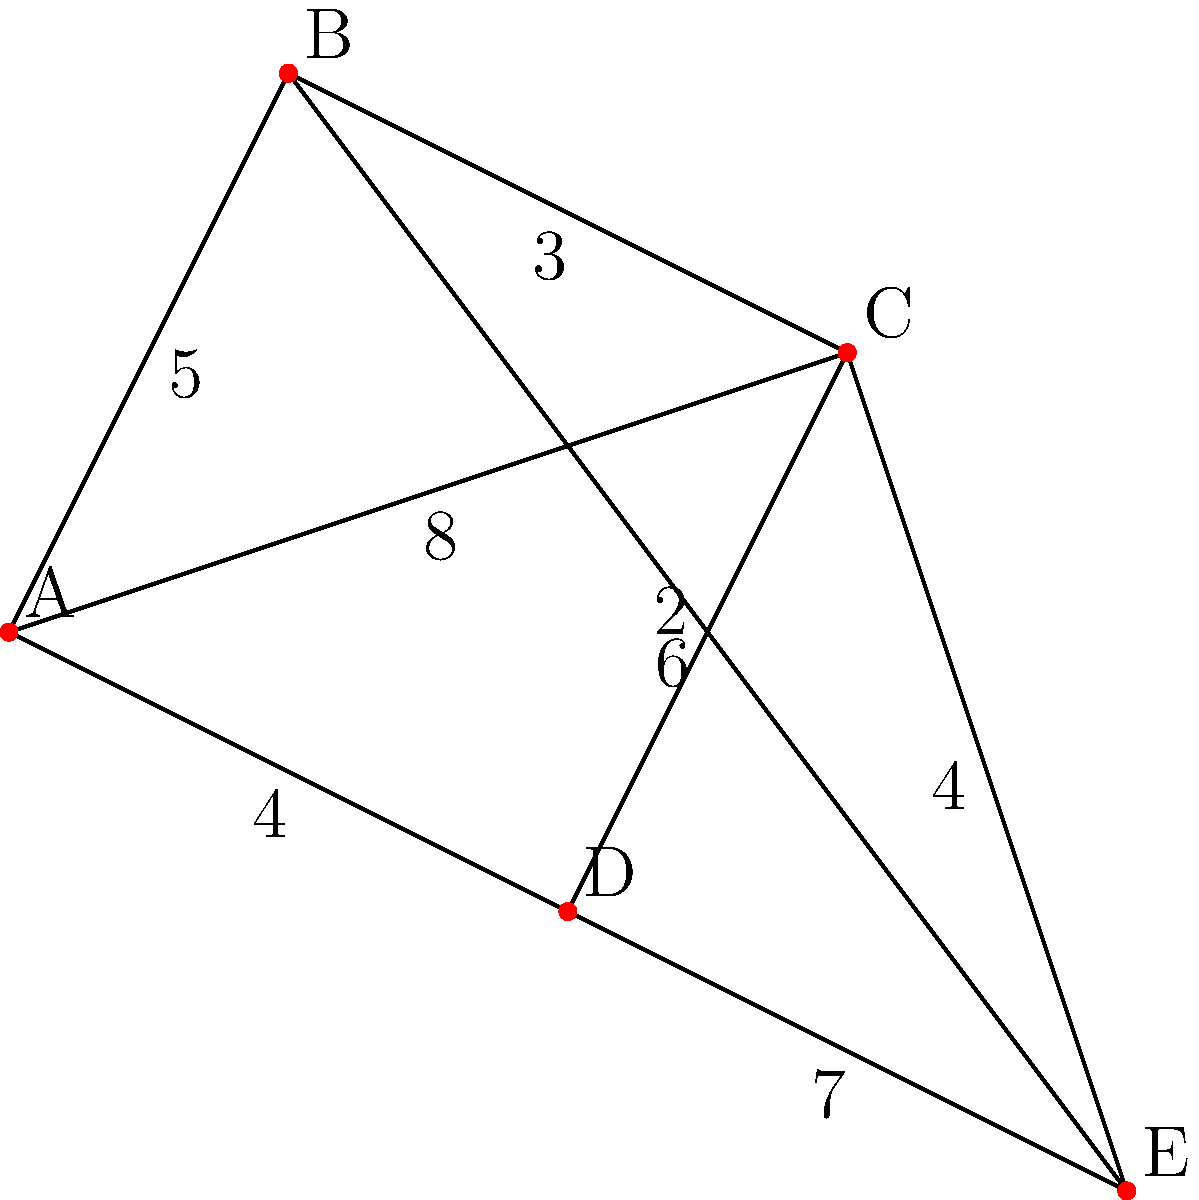Ahoy there, fellow island enthusiasts! Imagine you're planning the ultimate Caribbean cruise for our lucky listeners. On this graph, each port is represented by a letter, and the numbers on the lines show the sailing time in hours between ports. If our cruise ship starts at port A and needs to visit all ports before returning to A, what's the shortest possible route that covers all ports and returns to the starting point? Give the sequence of ports and the total sailing time. Let's navigate through this Caribbean adventure step-by-step, me hearties!

1) First, we need to find the shortest path that visits all ports and returns to A. This is known as the Traveling Salesman Problem.

2) For a small graph like this, we can use the brute force method to check all possible routes:

   A-B-C-D-E-A
   A-B-C-E-D-A
   A-B-D-C-E-A
   A-B-E-C-D-A
   A-C-B-D-E-A
   A-C-B-E-D-A
   A-C-D-B-E-A
   A-C-E-B-D-A
   A-D-B-C-E-A
   A-D-C-B-E-A
   A-E-B-C-D-A
   A-E-C-B-D-A

3) Let's calculate the total sailing time for each route:

   A-B-C-D-E-A: $5 + 3 + 2 + 7 + 8 = 25$ hours
   A-B-C-E-D-A: $5 + 3 + 4 + 7 + 4 = 23$ hours
   A-B-D-C-E-A: $5 + 6 + 2 + 4 + 8 = 25$ hours
   A-B-E-C-D-A: $5 + 6 + 4 + 2 + 4 = 21$ hours
   A-C-B-D-E-A: $8 + 3 + 6 + 7 + 8 = 32$ hours
   A-C-B-E-D-A: $8 + 3 + 6 + 7 + 4 = 28$ hours
   A-C-D-B-E-A: $8 + 2 + 6 + 6 + 8 = 30$ hours
   A-C-E-B-D-A: $8 + 4 + 6 + 6 + 4 = 28$ hours
   A-D-B-C-E-A: $4 + 6 + 3 + 4 + 8 = 25$ hours
   A-D-C-B-E-A: $4 + 2 + 3 + 6 + 8 = 23$ hours
   A-E-B-C-D-A: $8 + 6 + 3 + 2 + 4 = 23$ hours
   A-E-C-B-D-A: $8 + 4 + 3 + 6 + 4 = 25$ hours

4) The shortest route is A-B-E-C-D-A with a total sailing time of 21 hours.
Answer: A-B-E-C-D-A, 21 hours 